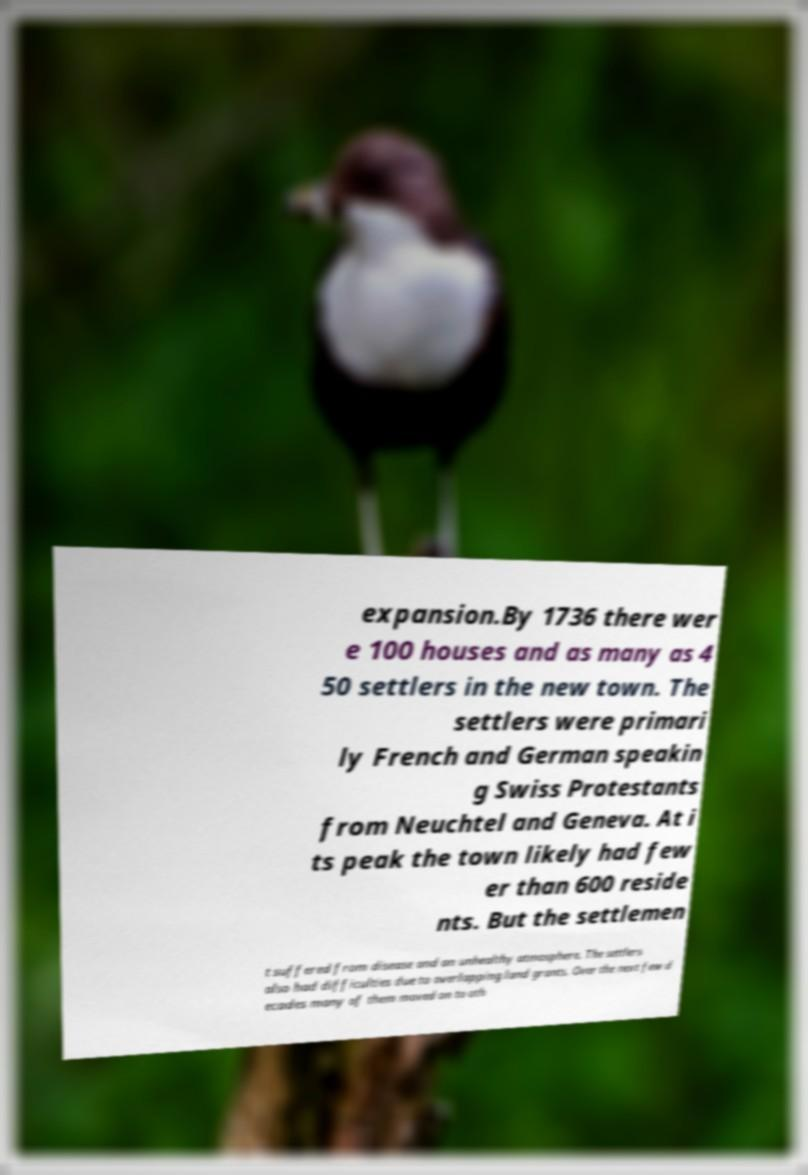Can you accurately transcribe the text from the provided image for me? expansion.By 1736 there wer e 100 houses and as many as 4 50 settlers in the new town. The settlers were primari ly French and German speakin g Swiss Protestants from Neuchtel and Geneva. At i ts peak the town likely had few er than 600 reside nts. But the settlemen t suffered from disease and an unhealthy atmosphere. The settlers also had difficulties due to overlapping land grants. Over the next few d ecades many of them moved on to oth 